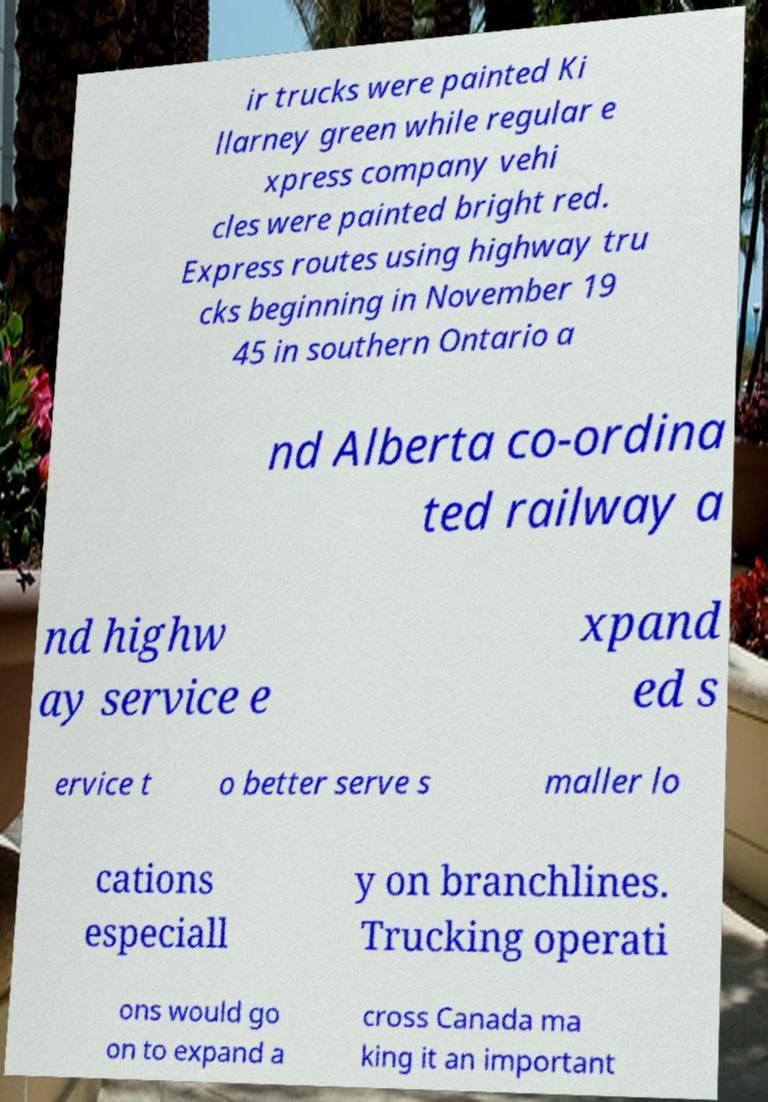Could you assist in decoding the text presented in this image and type it out clearly? ir trucks were painted Ki llarney green while regular e xpress company vehi cles were painted bright red. Express routes using highway tru cks beginning in November 19 45 in southern Ontario a nd Alberta co-ordina ted railway a nd highw ay service e xpand ed s ervice t o better serve s maller lo cations especiall y on branchlines. Trucking operati ons would go on to expand a cross Canada ma king it an important 